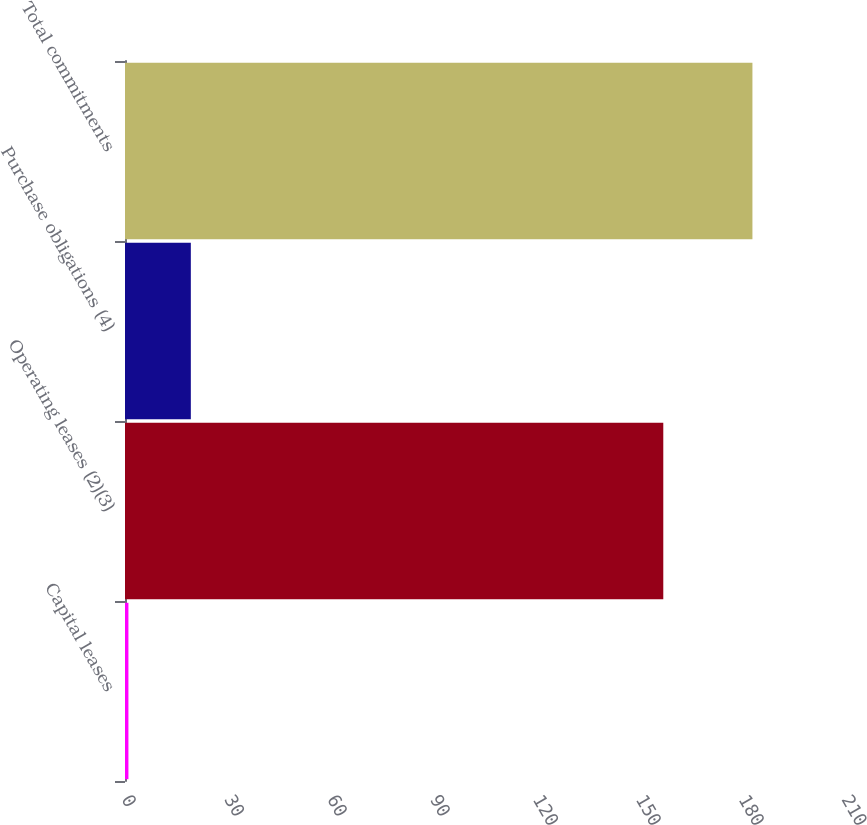Convert chart. <chart><loc_0><loc_0><loc_500><loc_500><bar_chart><fcel>Capital leases<fcel>Operating leases (2)(3)<fcel>Purchase obligations (4)<fcel>Total commitments<nl><fcel>1<fcel>157<fcel>19.2<fcel>183<nl></chart> 